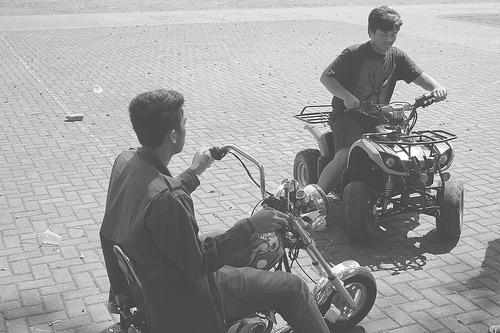Question: where is the motorcycle?
Choices:
A. In the fields.
B. In front of the four wheeler.
C. On the street.
D. In the parking lot.
Answer with the letter. Answer: B Question: how many wheels are there?
Choices:
A. 4.
B. 6.
C. 0.
D. 2.
Answer with the letter. Answer: B Question: what are the two people doing?
Choices:
A. Driving.
B. Riding.
C. Sailing.
D. Swimming.
Answer with the letter. Answer: B Question: what does the person on the motorcycle have on?
Choices:
A. Helmet.
B. Leather pants.
C. Jacket.
D. Heavy shoes.
Answer with the letter. Answer: C 